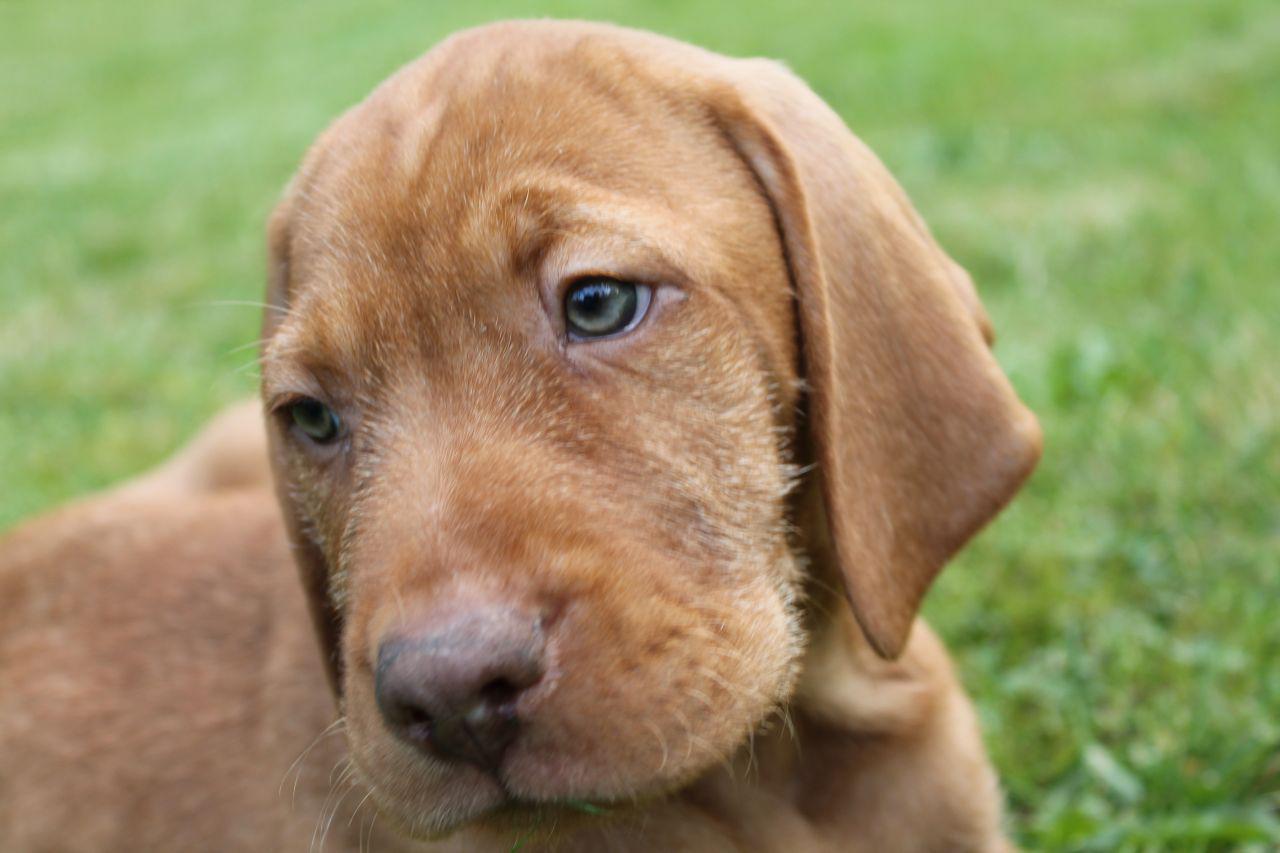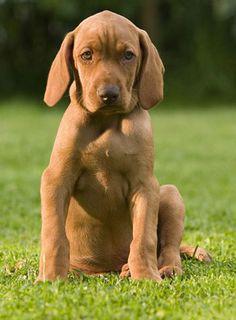The first image is the image on the left, the second image is the image on the right. Considering the images on both sides, is "Both dogs are wearing collars." valid? Answer yes or no. No. The first image is the image on the left, the second image is the image on the right. For the images shown, is this caption "There are two brown dogs in collars." true? Answer yes or no. No. 